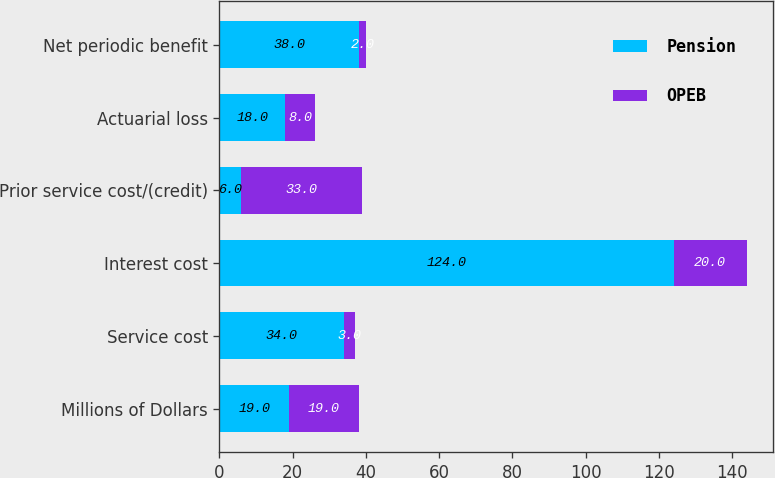Convert chart. <chart><loc_0><loc_0><loc_500><loc_500><stacked_bar_chart><ecel><fcel>Millions of Dollars<fcel>Service cost<fcel>Interest cost<fcel>Prior service cost/(credit)<fcel>Actuarial loss<fcel>Net periodic benefit<nl><fcel>Pension<fcel>19<fcel>34<fcel>124<fcel>6<fcel>18<fcel>38<nl><fcel>OPEB<fcel>19<fcel>3<fcel>20<fcel>33<fcel>8<fcel>2<nl></chart> 